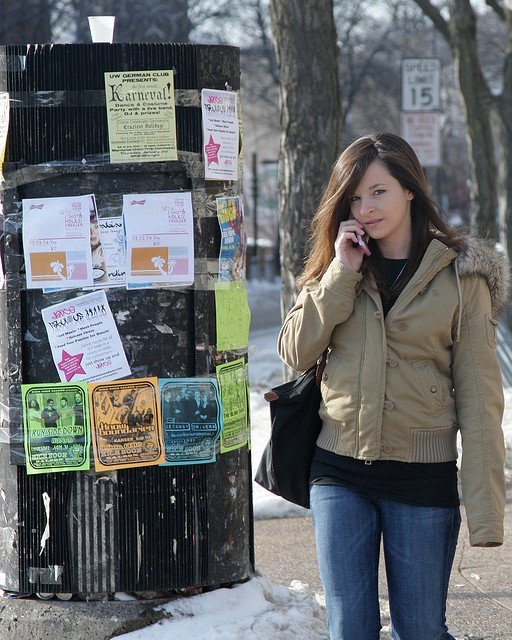Describe the objects in this image and their specific colors. I can see people in black, gray, and navy tones, handbag in black, gray, darkgray, and maroon tones, and cell phone in black, purple, and darkgray tones in this image. 